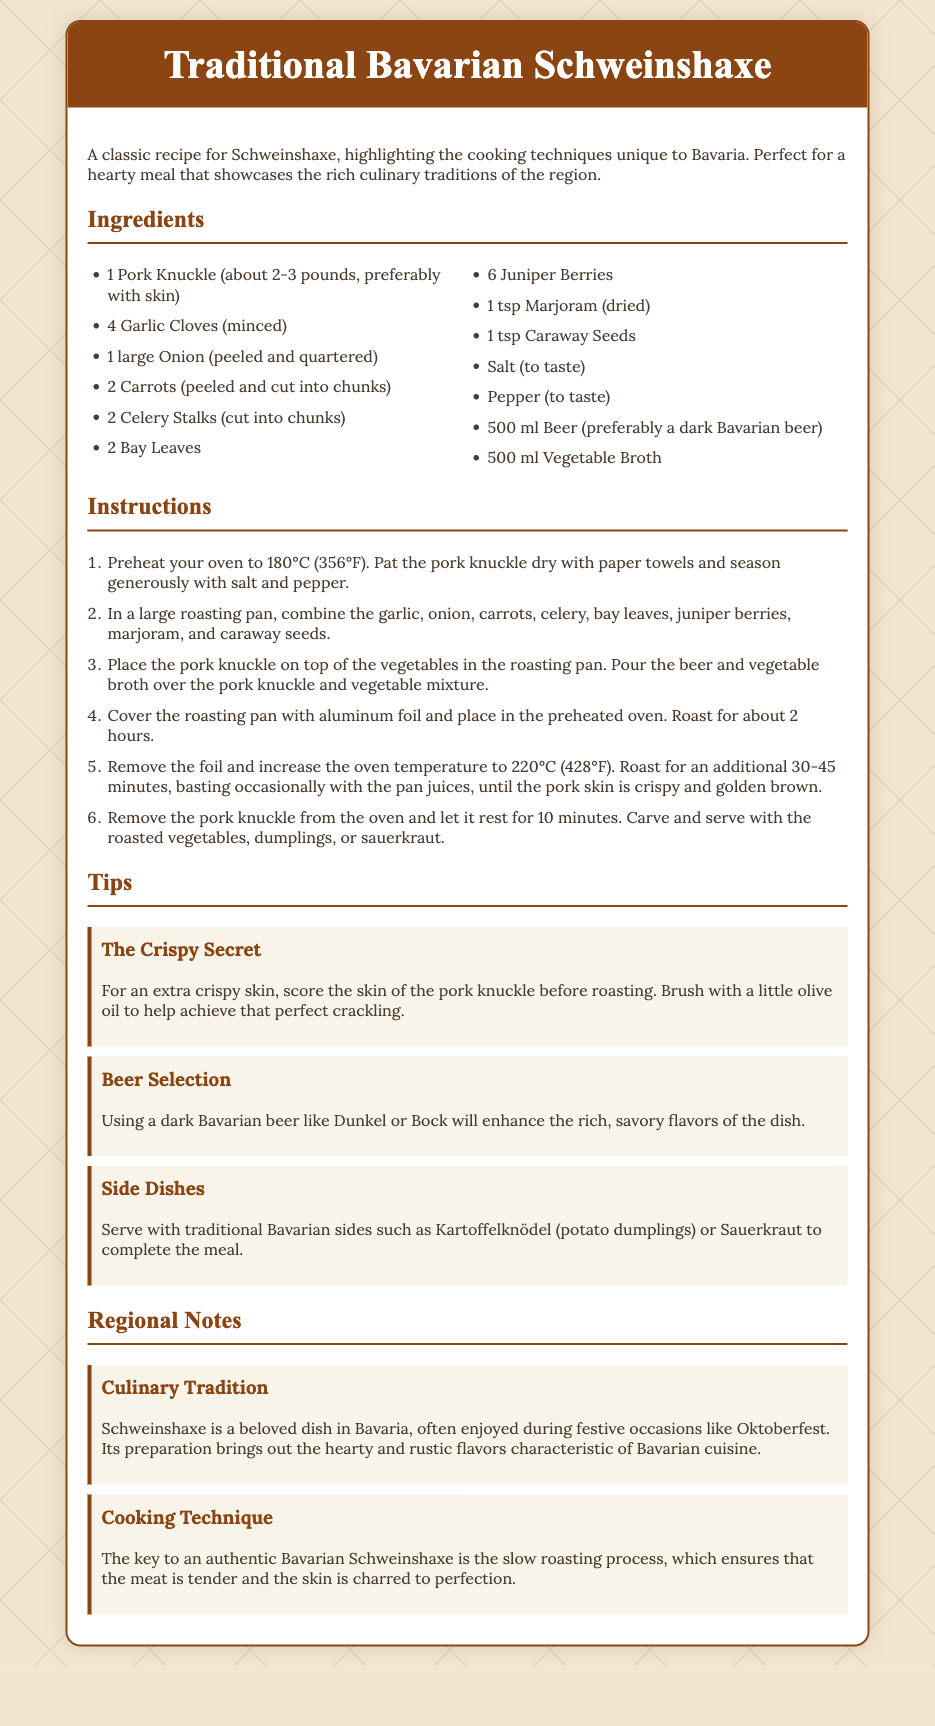What is the main ingredient? The main ingredient for the Schweinshaxe is a pork knuckle, as listed in the ingredients section.
Answer: Pork Knuckle What temperature should the oven be preheated to? The document specifies the temperature for preheating the oven at the beginning of the instructions.
Answer: 180°C How long should the pork knuckle be roasted initially? The instructions state that the pork knuckle should be covered and roasted for about 2 hours before removing the foil.
Answer: 2 hours What type of beer is recommended? The tips section suggests using a specific type of beer that enhances the dish's flavors.
Answer: Dark Bavarian beer What traditional side dishes are mentioned? The tips provide suggestions for side dishes that complement the Schweinshaxe.
Answer: Kartoffelknödel or Sauerkraut What is emphasized in the cooking technique section? The regional notes outline a specific cooking method that is crucial for the dish.
Answer: Slow roasting process What is the final resting time for the pork knuckle? The instructions state how long to let the pork knuckle rest before serving.
Answer: 10 minutes What culinary occasion is Schweinshaxe often enjoyed? The regional notes mention occasions where the dish is popular, highlighting its cultural significance.
Answer: Oktoberfest 